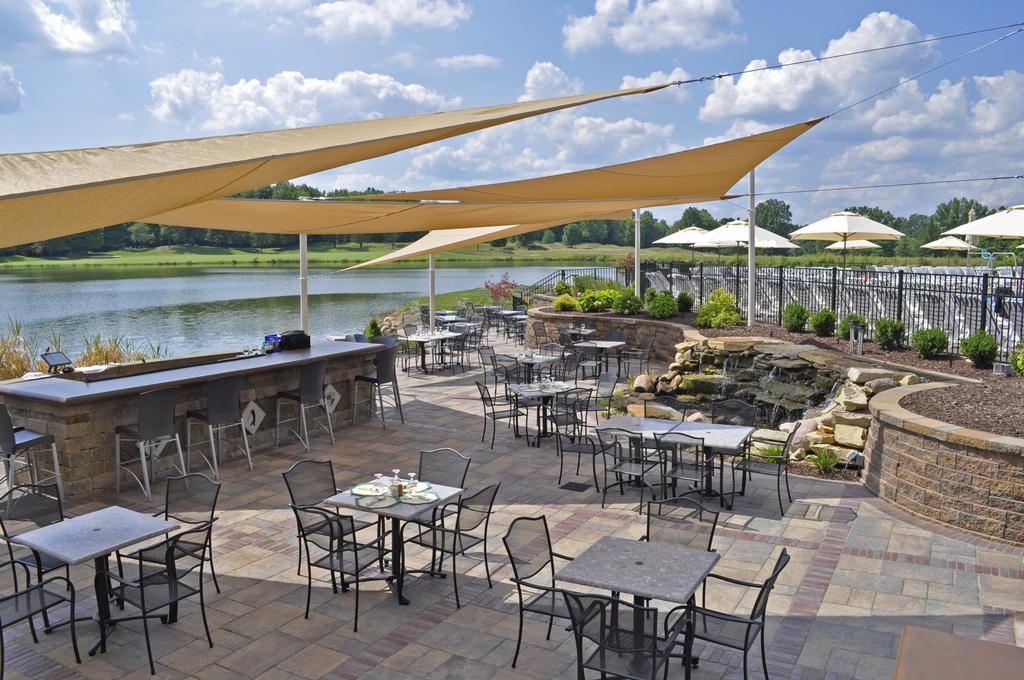Please provide a concise description of this image. In this image I can see the floor, few chairs, few tables, few tents which are brown in color, few cream colored umbrellas, few plants which are green in color, the metal railing, the water and few trees which are green in color. In the background I can see the sky. 